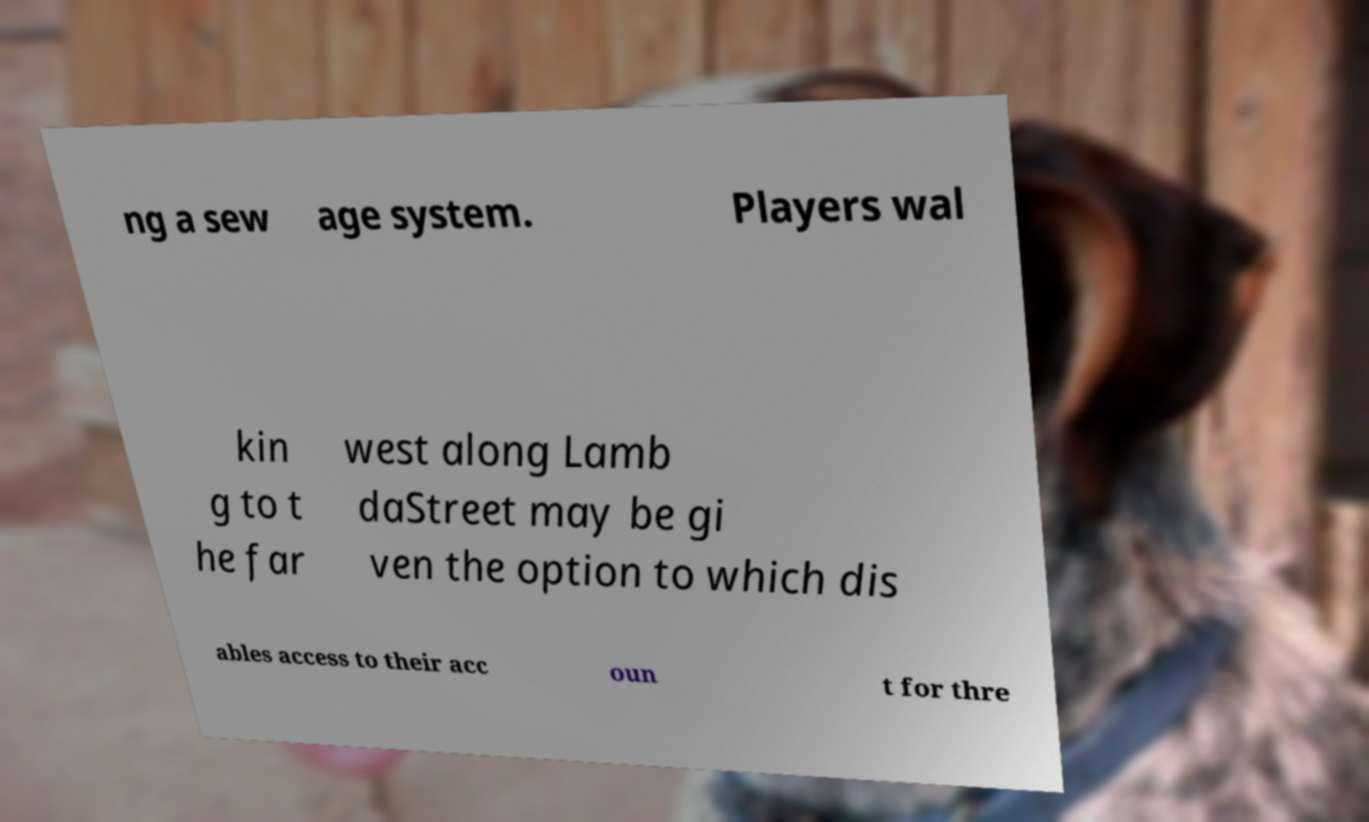For documentation purposes, I need the text within this image transcribed. Could you provide that? ng a sew age system. Players wal kin g to t he far west along Lamb daStreet may be gi ven the option to which dis ables access to their acc oun t for thre 